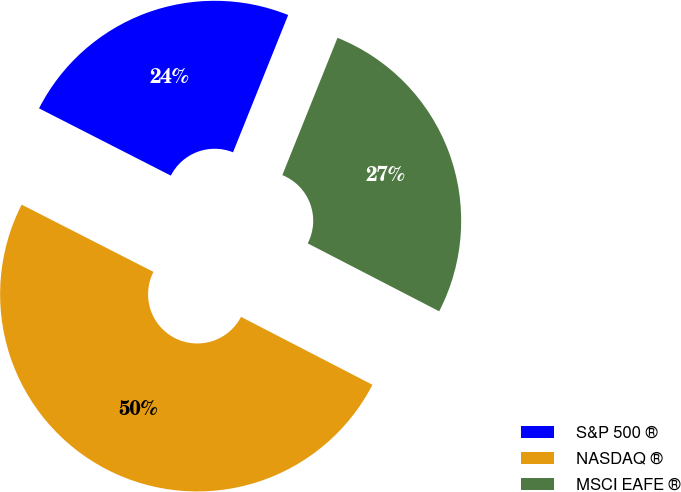<chart> <loc_0><loc_0><loc_500><loc_500><pie_chart><fcel>S&P 500 ®<fcel>NASDAQ ®<fcel>MSCI EAFE ®<nl><fcel>23.57%<fcel>49.92%<fcel>26.51%<nl></chart> 